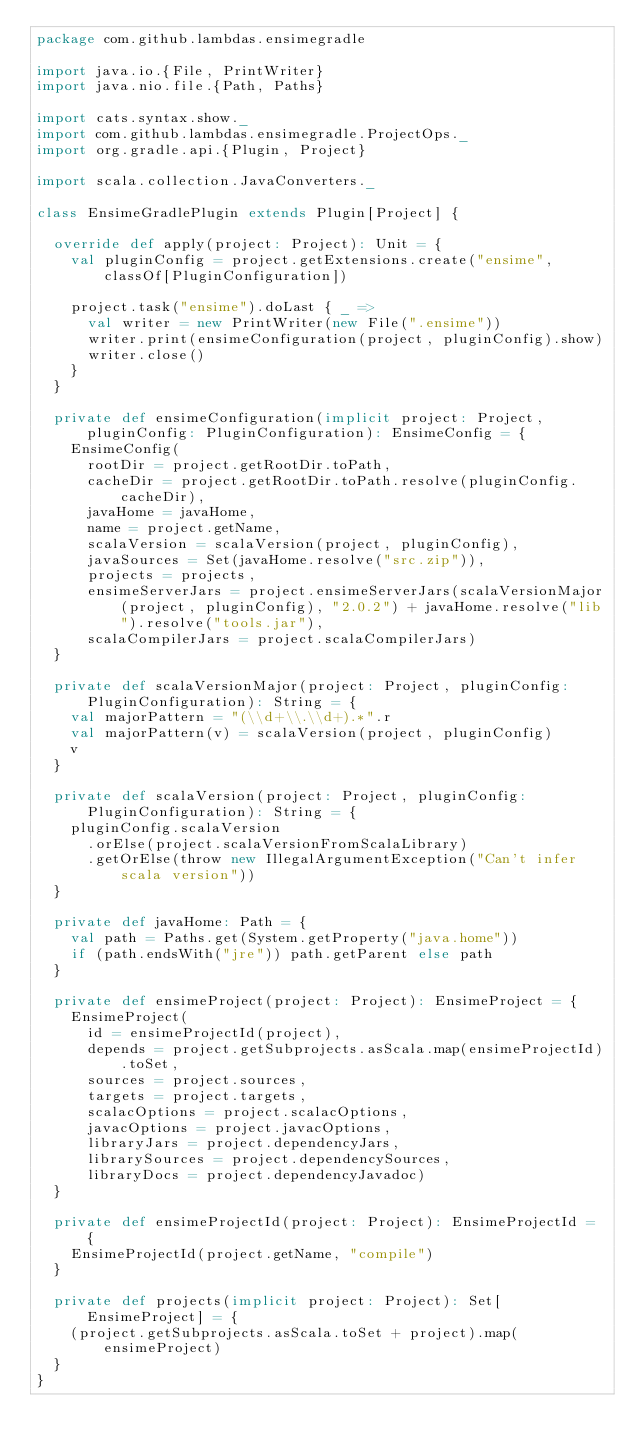<code> <loc_0><loc_0><loc_500><loc_500><_Scala_>package com.github.lambdas.ensimegradle

import java.io.{File, PrintWriter}
import java.nio.file.{Path, Paths}

import cats.syntax.show._
import com.github.lambdas.ensimegradle.ProjectOps._
import org.gradle.api.{Plugin, Project}

import scala.collection.JavaConverters._

class EnsimeGradlePlugin extends Plugin[Project] {

  override def apply(project: Project): Unit = {
    val pluginConfig = project.getExtensions.create("ensime", classOf[PluginConfiguration])

    project.task("ensime").doLast { _ =>
      val writer = new PrintWriter(new File(".ensime"))
      writer.print(ensimeConfiguration(project, pluginConfig).show)
      writer.close()
    }
  }

  private def ensimeConfiguration(implicit project: Project, pluginConfig: PluginConfiguration): EnsimeConfig = {
    EnsimeConfig(
      rootDir = project.getRootDir.toPath,
      cacheDir = project.getRootDir.toPath.resolve(pluginConfig.cacheDir),
      javaHome = javaHome,
      name = project.getName,
      scalaVersion = scalaVersion(project, pluginConfig),
      javaSources = Set(javaHome.resolve("src.zip")),
      projects = projects,
      ensimeServerJars = project.ensimeServerJars(scalaVersionMajor(project, pluginConfig), "2.0.2") + javaHome.resolve("lib").resolve("tools.jar"),
      scalaCompilerJars = project.scalaCompilerJars)
  }

  private def scalaVersionMajor(project: Project, pluginConfig: PluginConfiguration): String = {
    val majorPattern = "(\\d+\\.\\d+).*".r
    val majorPattern(v) = scalaVersion(project, pluginConfig)
    v
  }

  private def scalaVersion(project: Project, pluginConfig: PluginConfiguration): String = {
    pluginConfig.scalaVersion
      .orElse(project.scalaVersionFromScalaLibrary)
      .getOrElse(throw new IllegalArgumentException("Can't infer scala version"))
  }

  private def javaHome: Path = {
    val path = Paths.get(System.getProperty("java.home"))
    if (path.endsWith("jre")) path.getParent else path
  }

  private def ensimeProject(project: Project): EnsimeProject = {
    EnsimeProject(
      id = ensimeProjectId(project),
      depends = project.getSubprojects.asScala.map(ensimeProjectId).toSet,
      sources = project.sources,
      targets = project.targets,
      scalacOptions = project.scalacOptions,
      javacOptions = project.javacOptions,
      libraryJars = project.dependencyJars,
      librarySources = project.dependencySources,
      libraryDocs = project.dependencyJavadoc)
  }

  private def ensimeProjectId(project: Project): EnsimeProjectId = {
    EnsimeProjectId(project.getName, "compile")
  }

  private def projects(implicit project: Project): Set[EnsimeProject] = {
    (project.getSubprojects.asScala.toSet + project).map(ensimeProject)
  }
}

</code> 